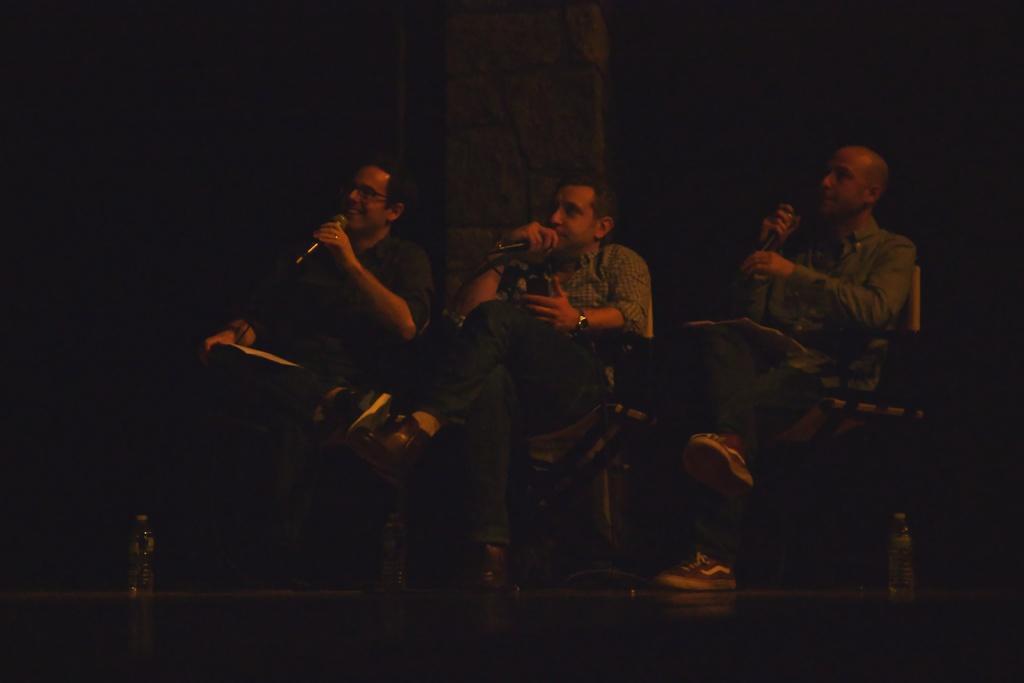Can you describe this image briefly? In the center of the image there are three people sitting on chairs holding a mic. In the background of the image there is pillar. At the bottom of the image there is floor. 